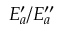Convert formula to latex. <formula><loc_0><loc_0><loc_500><loc_500>E _ { a } ^ { \prime } / E _ { a } ^ { \prime \prime }</formula> 